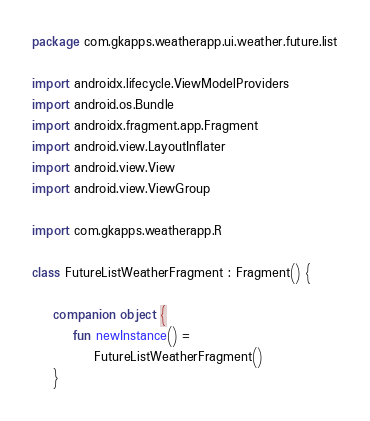Convert code to text. <code><loc_0><loc_0><loc_500><loc_500><_Kotlin_>package com.gkapps.weatherapp.ui.weather.future.list

import androidx.lifecycle.ViewModelProviders
import android.os.Bundle
import androidx.fragment.app.Fragment
import android.view.LayoutInflater
import android.view.View
import android.view.ViewGroup

import com.gkapps.weatherapp.R

class FutureListWeatherFragment : Fragment() {

    companion object {
        fun newInstance() =
            FutureListWeatherFragment()
    }
</code> 